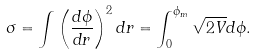<formula> <loc_0><loc_0><loc_500><loc_500>\sigma = \int \left ( \frac { d \phi } { d r } \right ) ^ { 2 } d r = \int _ { 0 } ^ { \phi _ { m } } \sqrt { 2 V } d \phi .</formula> 